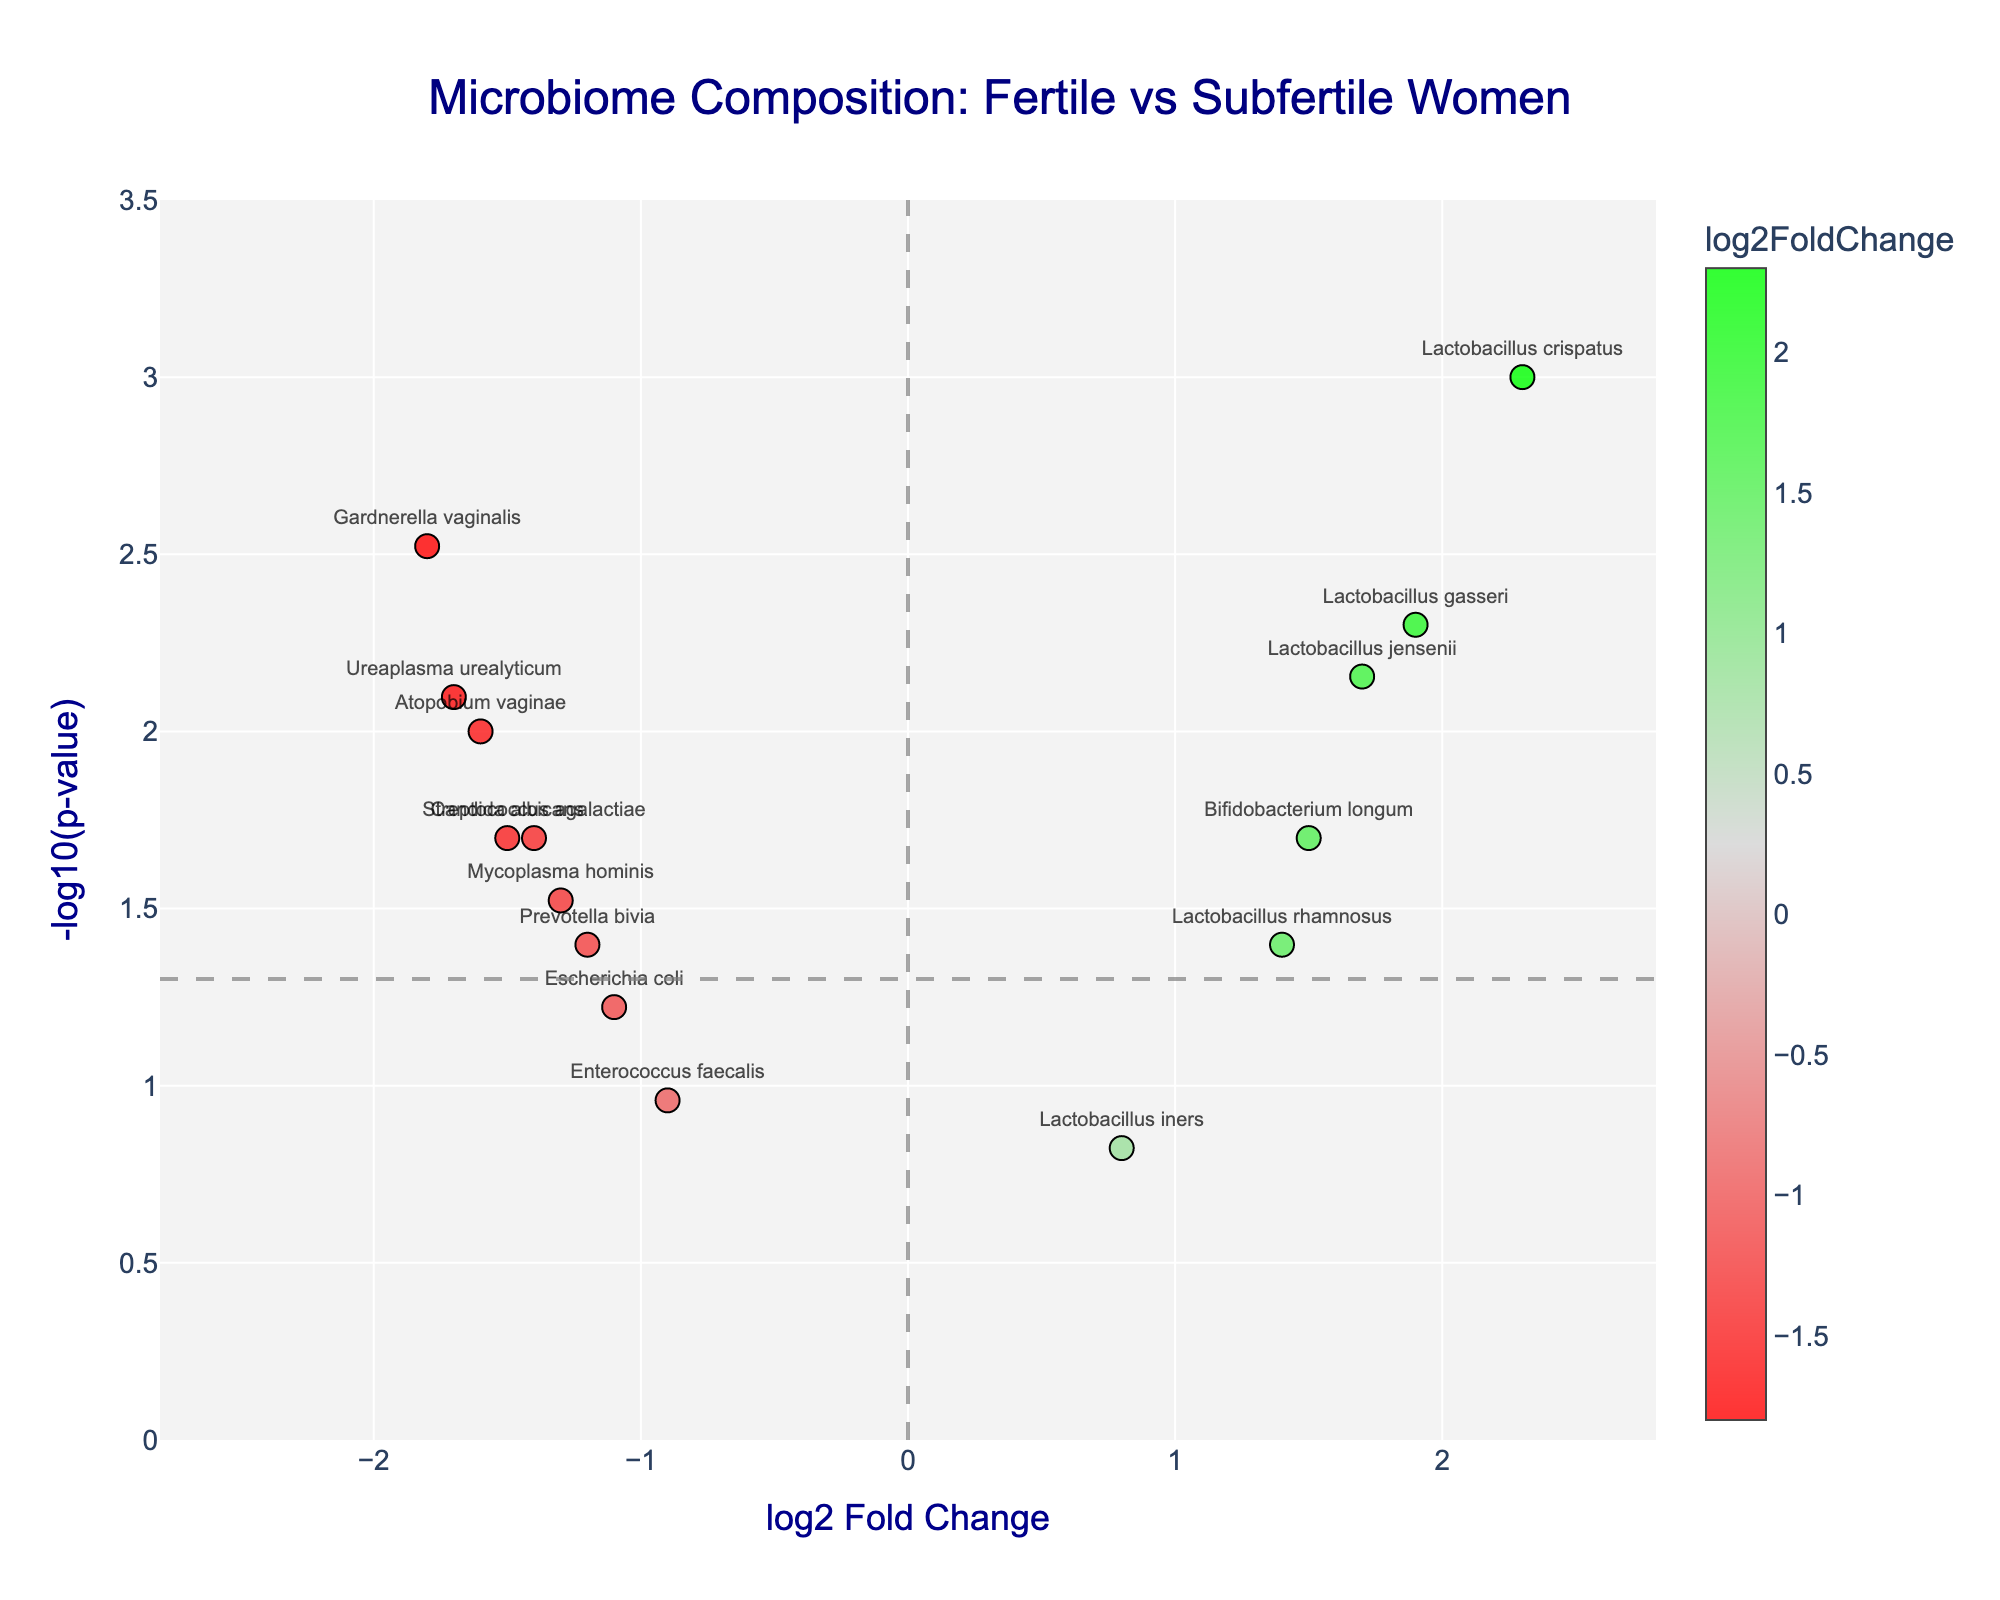What's the title of the plot? The title is located at the top of the plot and gives a summary of what the figure represents. Based on the provided code, the title of the plot is "Microbiome Composition: Fertile vs Subfertile Women".
Answer: Microbiome Composition: Fertile vs Subfertile Women Which bacteria have a positive log2 fold change and are significant (p-value < 0.05)? A positive log2 fold change indicates that the bacteria are more abundant in fertile women. Significant bacteria are those with a p-value < 0.05, which would be above the horizontal grey line on the plot. Lactobacillus crispatus, Lactobacillus gasseri, Lactobacillus jensenii, and Bifidobacterium longum have positive log2 fold changes and p-values below 0.05.
Answer: Lactobacillus crispatus, Lactobacillus gasseri, Lactobacillus jensenii, Bifidobacterium longum Which bacteria have the most negative log2 fold change and what is its p-value? The most negative log2 fold change indicates the bacteria are more abundant in subfertile women. In the plot, Gardnerella vaginalis has the most negative log2 fold change. The p-value of Gardnerella vaginalis can be found by looking at its position on the y-axis.
Answer: Gardnerella vaginalis, 0.003 What is the log2 fold change and -log10(p-value) for Lactobacillus crispatus? Find Lactobacillus crispatus on the plot, then read its x (log2 fold change) and y (-log10(p-value)) values. For Lactobacillus crispatus, the x value is 2.3 and the y value is -log10(0.001). Calculate -log10(0.001), which equals 3.
Answer: 2.3, 3 How many bacteria have a p-value < 0.05? Count the number of data points above the horizontal grey line (which represents -log10(0.05)). Based on the provided data and plot visualization, there are 12 bacteria with a p-value < 0.05.
Answer: 12 Which bacteria are neither significantly abundant in fertile nor subfertile women? These are bacteria with a p-value >= 0.05, found below the horizontal grey line in the plot. For these bacteria, log2 fold change may be positive or negative. Based on the provided data, Lactobacillus iners and Enterococcus faecalis are not significantly different.
Answer: Lactobacillus iners, Enterococcus faecalis Which bacteria have a positive log2 fold change but is not significant? A positive log2 fold change indicates more abundance in fertile women, but if it isn't significant, its p-value >= 0.05. Based on the data, Lactobacillus iners has a positive log2 fold change (0.8) but a p-value of 0.15, which is not significant.
Answer: Lactobacillus iners What does a point above the horizontal grey line represent in the context of p-values? The horizontal grey line represents the threshold of -log10(p-value) = -log10(0.05). Points above this line have a p-value < 0.05, indicating statistical significance in the context of this study.
Answer: p-value < 0.05 